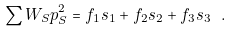Convert formula to latex. <formula><loc_0><loc_0><loc_500><loc_500>\sum W _ { S } p _ { S } ^ { 2 } = f _ { 1 } s _ { 1 } + f _ { 2 } s _ { 2 } + f _ { 3 } s _ { 3 } \ .</formula> 